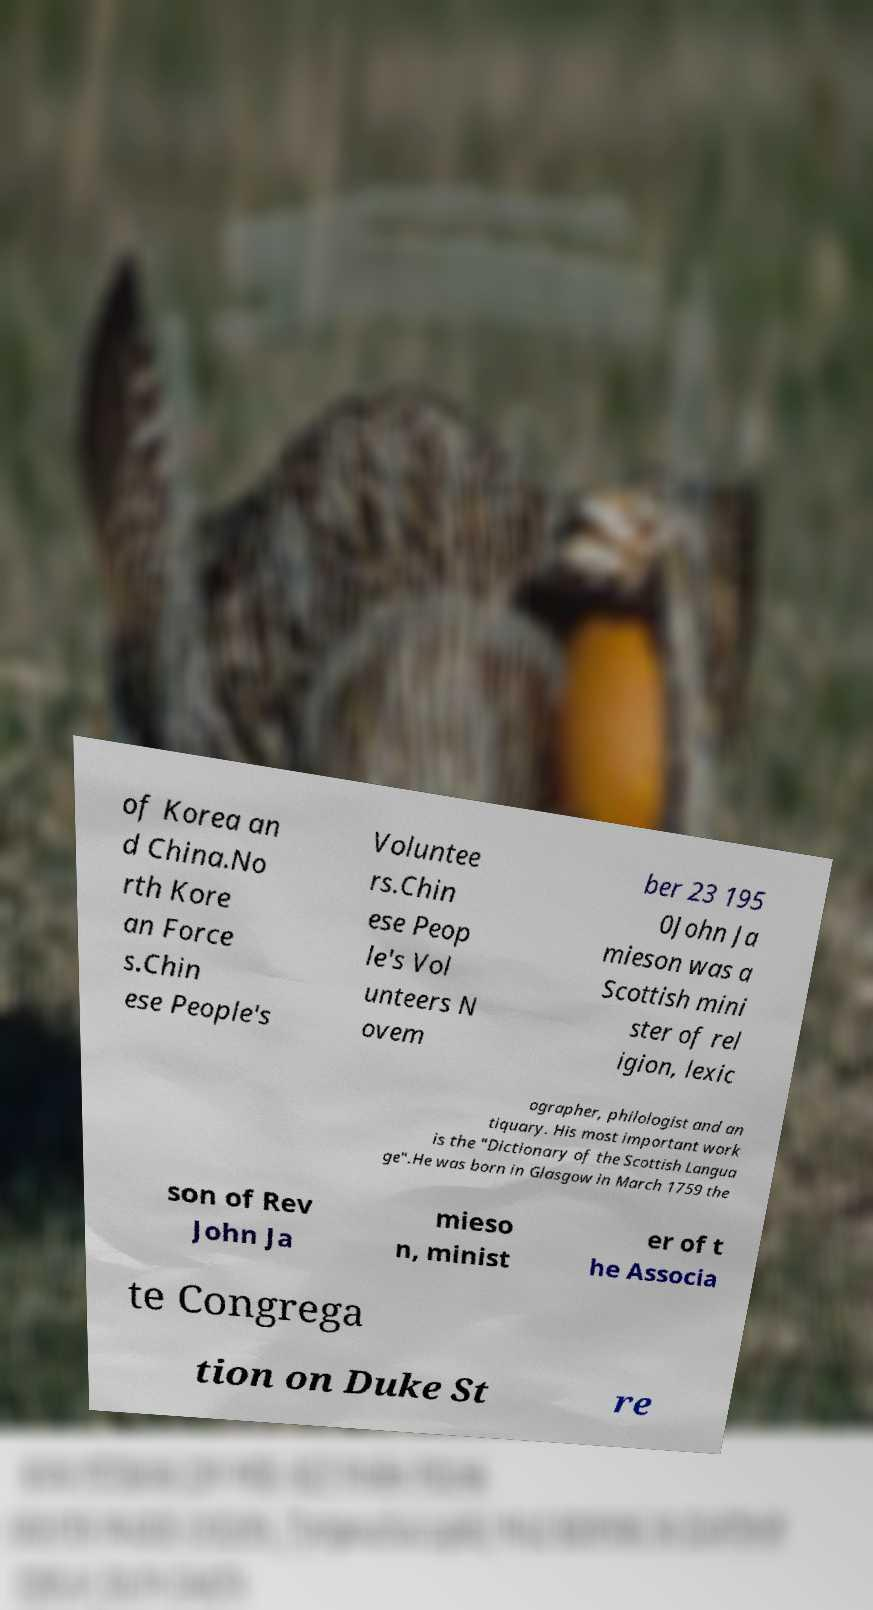Could you assist in decoding the text presented in this image and type it out clearly? of Korea an d China.No rth Kore an Force s.Chin ese People's Voluntee rs.Chin ese Peop le's Vol unteers N ovem ber 23 195 0John Ja mieson was a Scottish mini ster of rel igion, lexic ographer, philologist and an tiquary. His most important work is the "Dictionary of the Scottish Langua ge".He was born in Glasgow in March 1759 the son of Rev John Ja mieso n, minist er of t he Associa te Congrega tion on Duke St re 